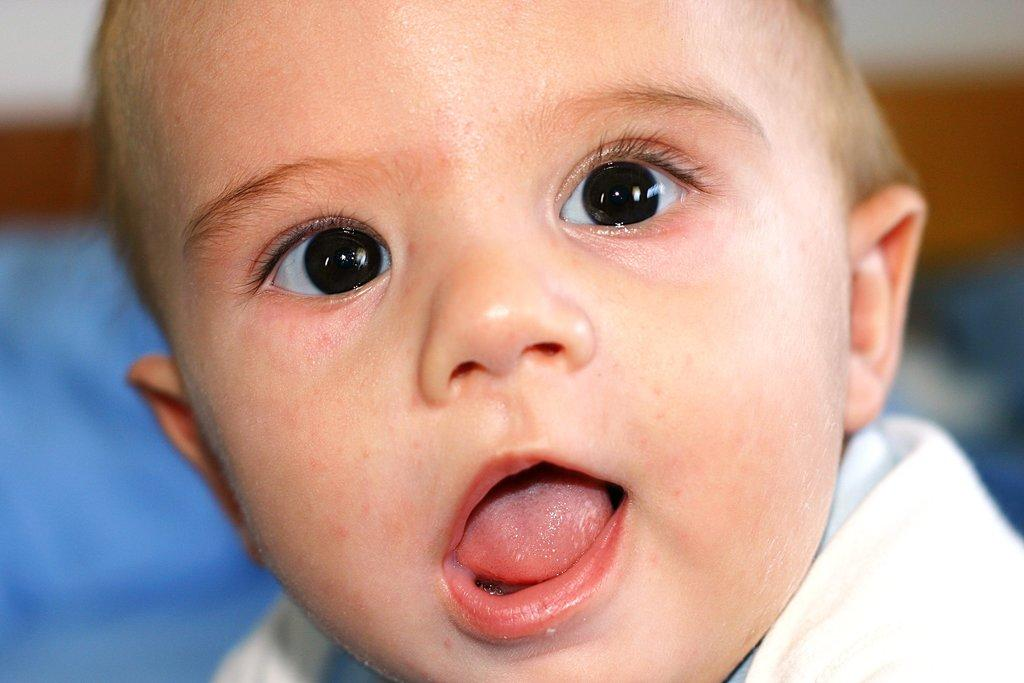What is the main subject of the image? There is a baby in the image. Can you describe the background of the image? The background of the image is blurred. What type of expansion can be seen in the image? There is no expansion present in the image; it features a baby and a blurred background. What sound is being made by the baby in the image? The image does not provide any information about the baby's sound, as it is a still image. 